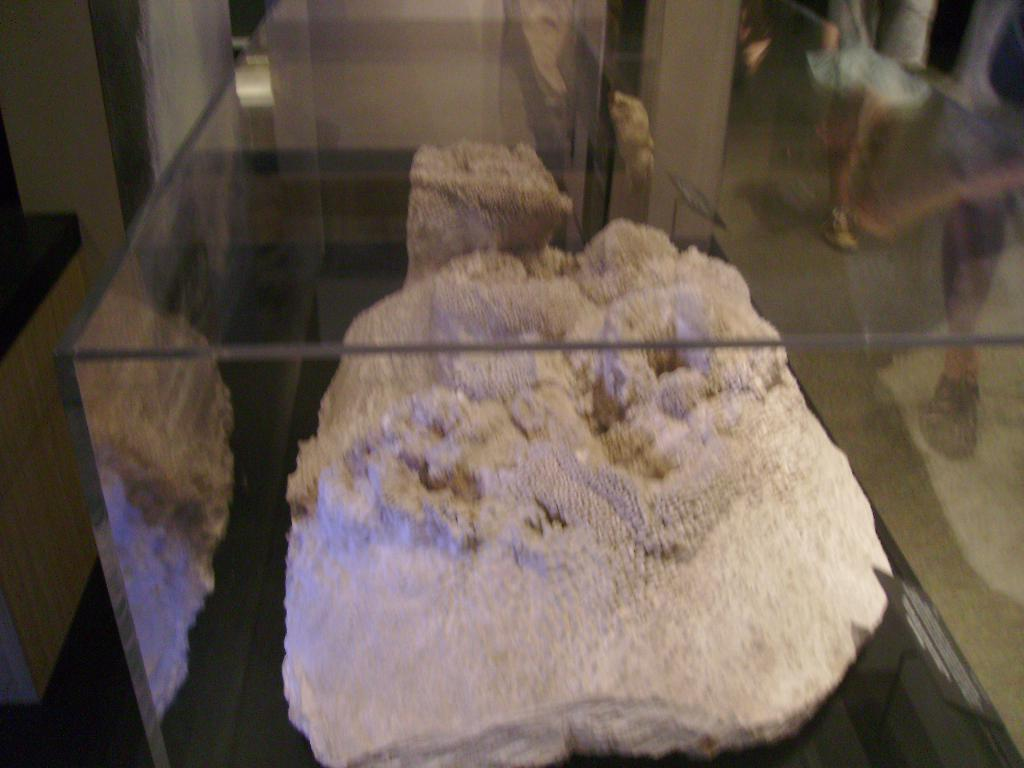What is inside the glass box in the image? There is a rock in a glass box in the image. Can you describe anything visible on the glass surface? Yes, there is a reflection of people's legs on the transparent glass. What type of tool is the carpenter using to join the pieces of wood in the image? There is no carpenter or woodworking activity present in the image; it features a rock in a glass box and a reflection of people's legs on the glass surface. 